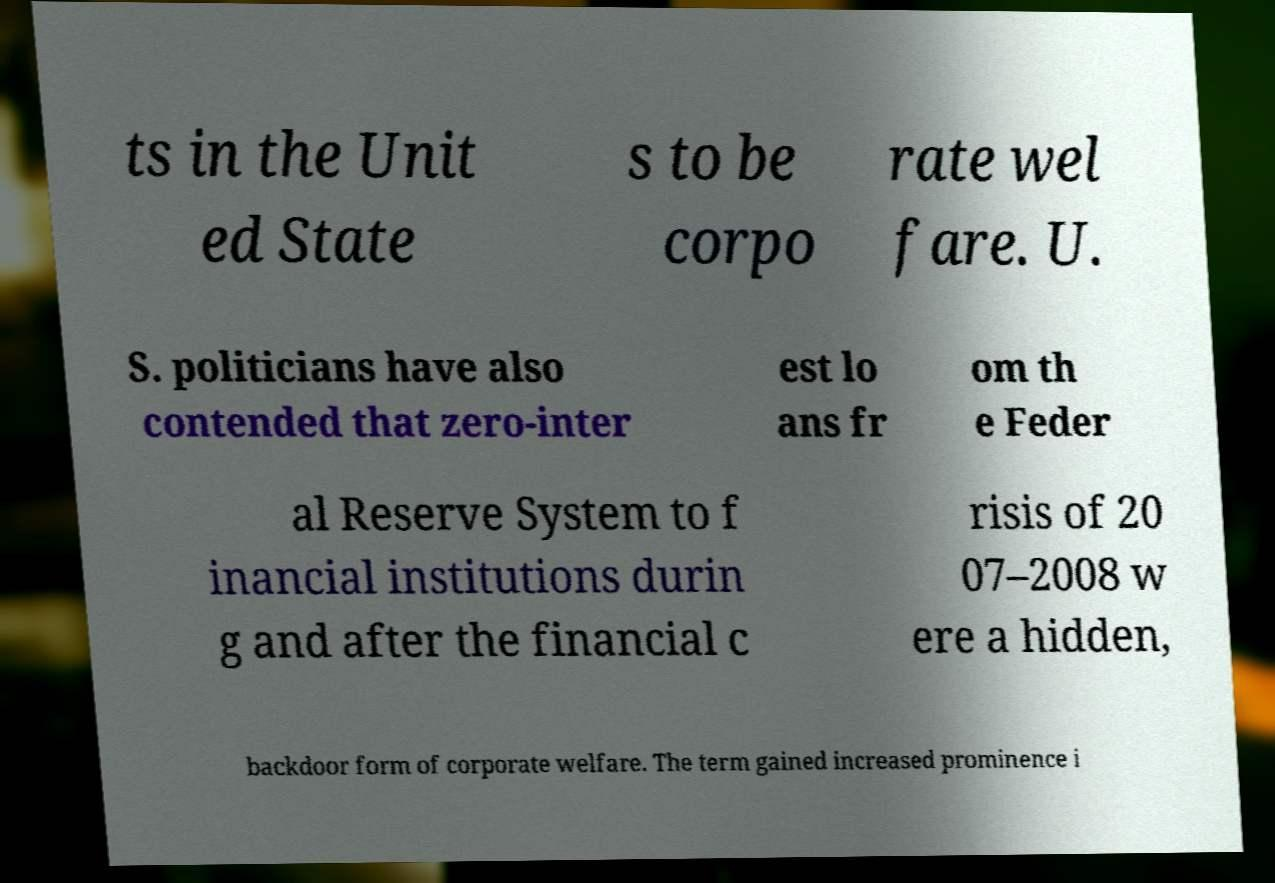For documentation purposes, I need the text within this image transcribed. Could you provide that? ts in the Unit ed State s to be corpo rate wel fare. U. S. politicians have also contended that zero-inter est lo ans fr om th e Feder al Reserve System to f inancial institutions durin g and after the financial c risis of 20 07–2008 w ere a hidden, backdoor form of corporate welfare. The term gained increased prominence i 